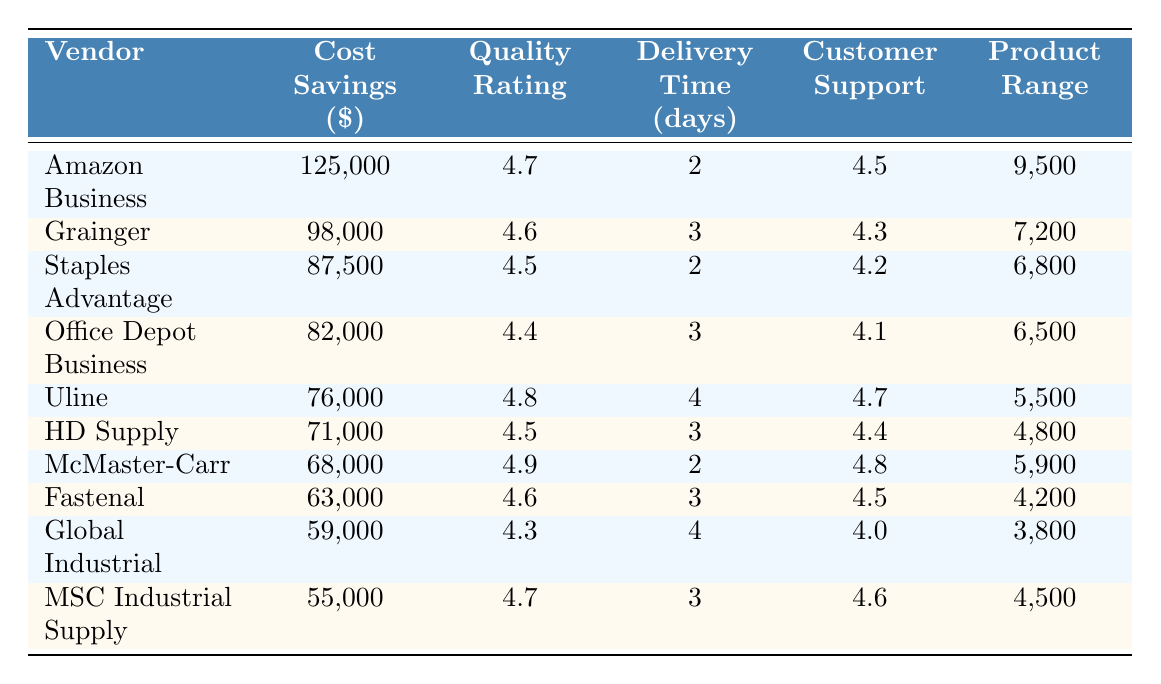What is the vendor with the highest cost savings? According to the table, Amazon Business has the highest cost savings of $125,000.
Answer: Amazon Business Which vendor has the lowest quality rating? By analyzing the quality ratings in the table, Global Industrial has the lowest quality rating at 4.3.
Answer: Global Industrial What is the total cost savings of the top three vendors? The total cost savings for the top three vendors is calculated as $125,000 (Amazon Business) + $98,000 (Grainger) + $87,500 (Staples Advantage) = $310,500.
Answer: $310,500 Which vendor offers the fastest delivery time, and how many days is it? Examining the delivery times in the table, both Amazon Business and Staples Advantage offer the fastest delivery time of 2 days.
Answer: Amazon Business, 2 days What is the average quality rating of all the vendors? To find the average quality rating, sum the quality ratings (4.7 + 4.6 + 4.5 + 4.4 + 4.8 + 4.5 + 4.9 + 4.6 + 4.3 + 4.7 = 46.6) and divide by the number of vendors (10), resulting in an average of 46.6 / 10 = 4.66.
Answer: 4.66 Is Uline's cost savings greater than the average cost savings of all vendors? The average cost savings is calculated as (125000 + 98000 + 87500 + 82000 + 76000 + 71000 + 68000 + 63000 + 59000 + 55000) / 10 = $75700. Since Uline's cost savings of $76,000 is greater than $75,700, the answer is Yes.
Answer: Yes How many vendors have a customer support rating above 4.5? By reviewing the customer support ratings, the following vendors have ratings above 4.5: Amazon Business (4.5), Uline (4.7), McMaster-Carr (4.8), and MSC Industrial Supply (4.6). Counting these, there are 4 vendors.
Answer: 4 What is the difference in cost savings between Amazon Business and the vendor with the least cost savings? The least cost savings is from MSC Industrial Supply at $55,000. The difference is calculated as $125,000 (Amazon Business) - $55,000 = $70,000.
Answer: $70,000 Which vendor has the largest product range, and how many products do they offer? Looking at the product range column, Amazon Business has the largest product range with 9,500 products.
Answer: Amazon Business, 9,500 products Do any vendors have the same quality rating? Comparing the quality ratings, both Uline and McMaster-Carr have a quality rating of 4.8, thus confirming that yes, there are vendors with the same quality rating.
Answer: Yes 